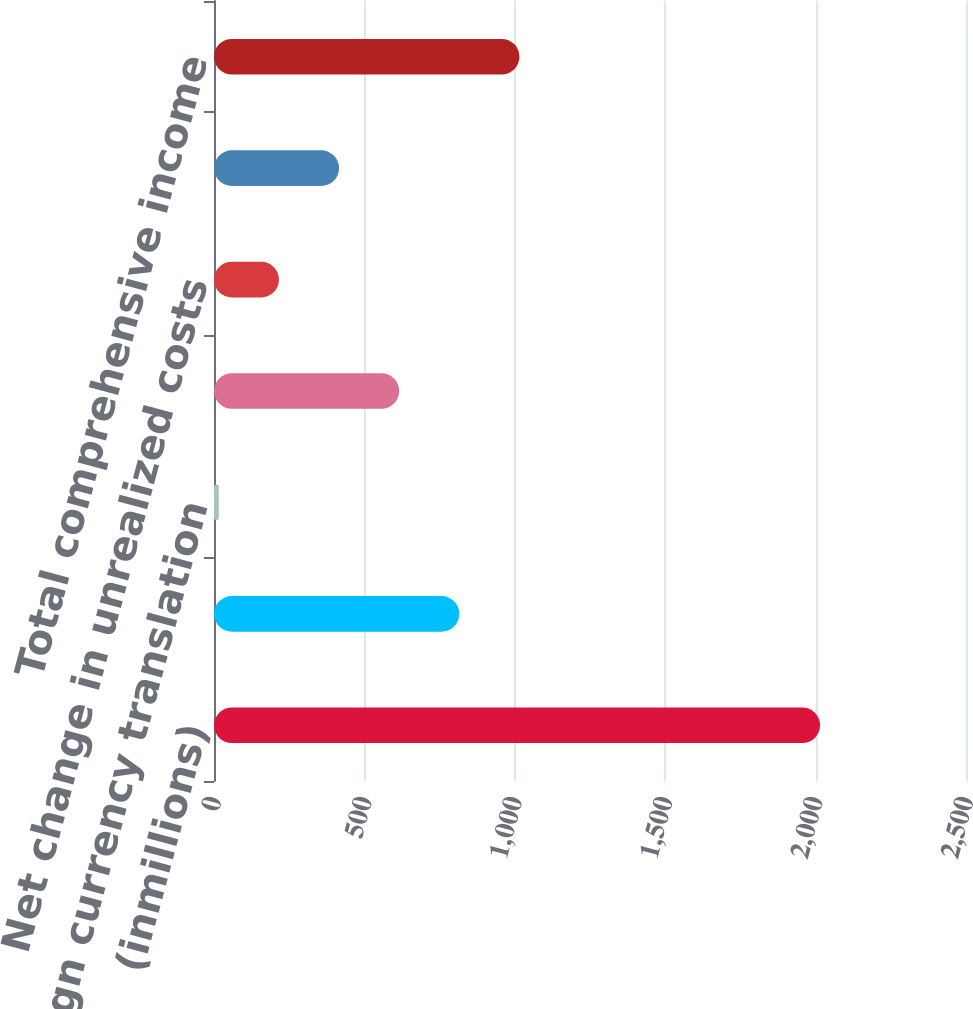Convert chart. <chart><loc_0><loc_0><loc_500><loc_500><bar_chart><fcel>(inmillions)<fcel>Net income (loss)<fcel>Foreign currency translation<fcel>Net change in unrealized gains<fcel>Net change in unrealized costs<fcel>Total other comprehensive<fcel>Total comprehensive income<nl><fcel>2015<fcel>815.6<fcel>16<fcel>615.7<fcel>215.9<fcel>415.8<fcel>1015.5<nl></chart> 